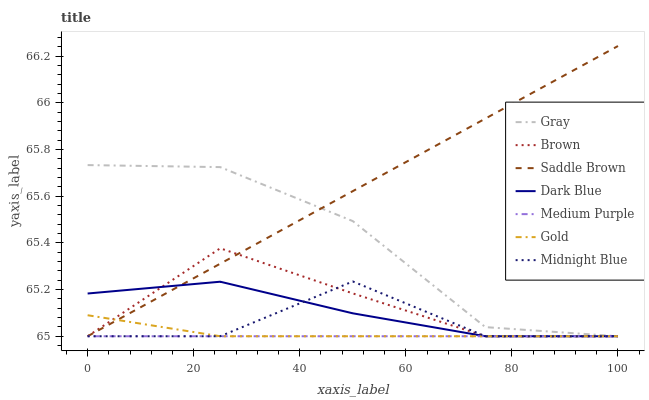Does Medium Purple have the minimum area under the curve?
Answer yes or no. Yes. Does Saddle Brown have the maximum area under the curve?
Answer yes or no. Yes. Does Midnight Blue have the minimum area under the curve?
Answer yes or no. No. Does Midnight Blue have the maximum area under the curve?
Answer yes or no. No. Is Medium Purple the smoothest?
Answer yes or no. Yes. Is Midnight Blue the roughest?
Answer yes or no. Yes. Is Gold the smoothest?
Answer yes or no. No. Is Gold the roughest?
Answer yes or no. No. Does Gray have the lowest value?
Answer yes or no. Yes. Does Saddle Brown have the highest value?
Answer yes or no. Yes. Does Midnight Blue have the highest value?
Answer yes or no. No. Does Dark Blue intersect Saddle Brown?
Answer yes or no. Yes. Is Dark Blue less than Saddle Brown?
Answer yes or no. No. Is Dark Blue greater than Saddle Brown?
Answer yes or no. No. 